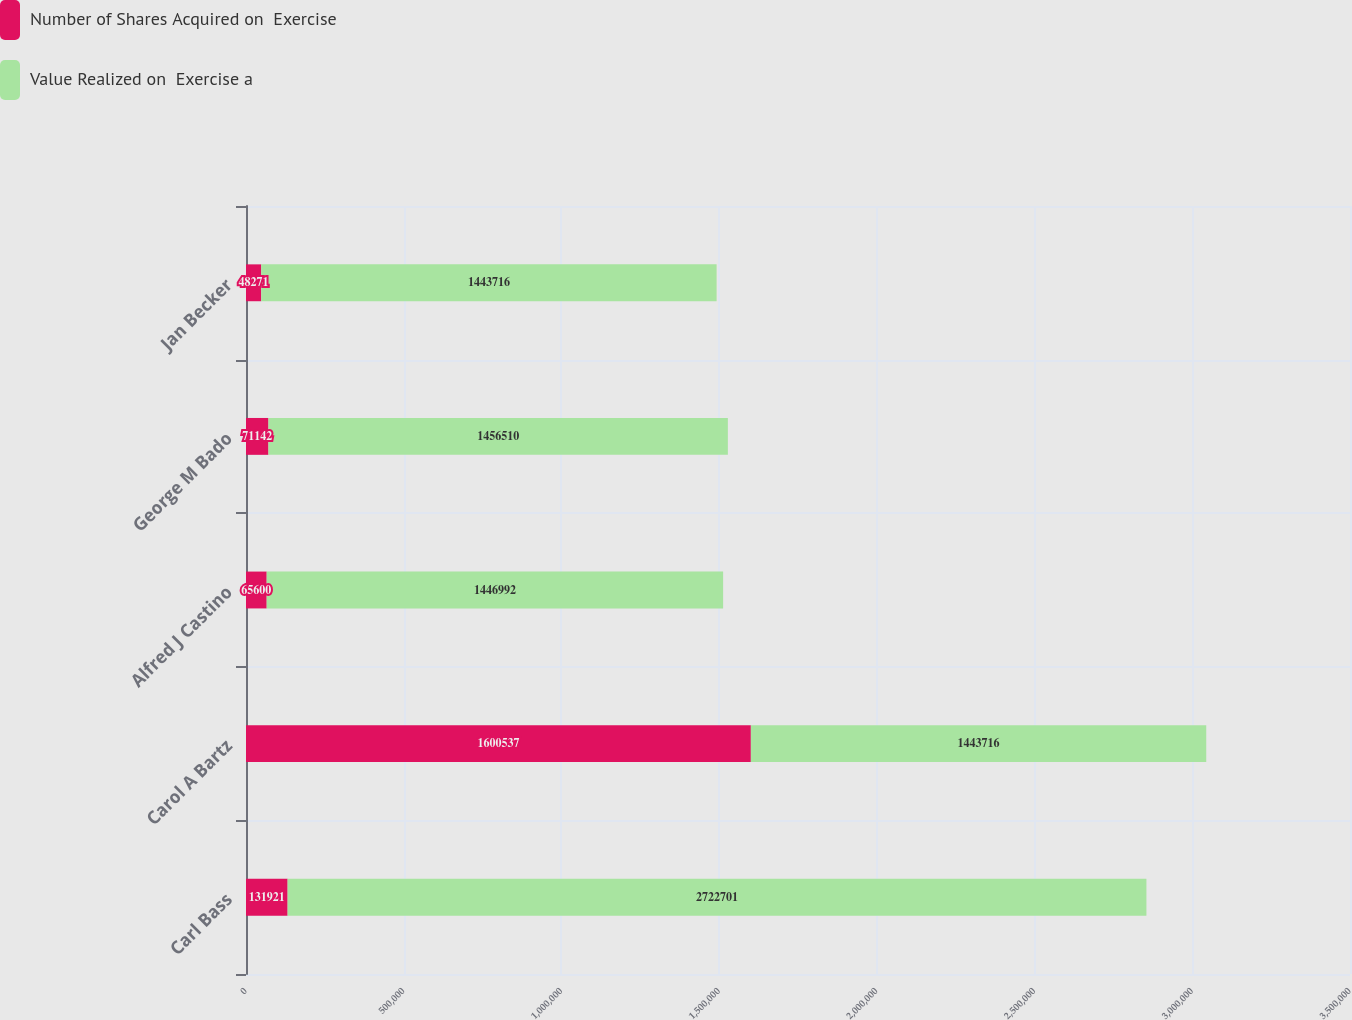Convert chart. <chart><loc_0><loc_0><loc_500><loc_500><stacked_bar_chart><ecel><fcel>Carl Bass<fcel>Carol A Bartz<fcel>Alfred J Castino<fcel>George M Bado<fcel>Jan Becker<nl><fcel>Number of Shares Acquired on  Exercise<fcel>131921<fcel>1.60054e+06<fcel>65600<fcel>71142<fcel>48271<nl><fcel>Value Realized on  Exercise a<fcel>2.7227e+06<fcel>1.44372e+06<fcel>1.44699e+06<fcel>1.45651e+06<fcel>1.44372e+06<nl></chart> 